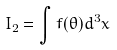<formula> <loc_0><loc_0><loc_500><loc_500>I _ { 2 } = \int f ( \theta ) d ^ { 3 } x</formula> 